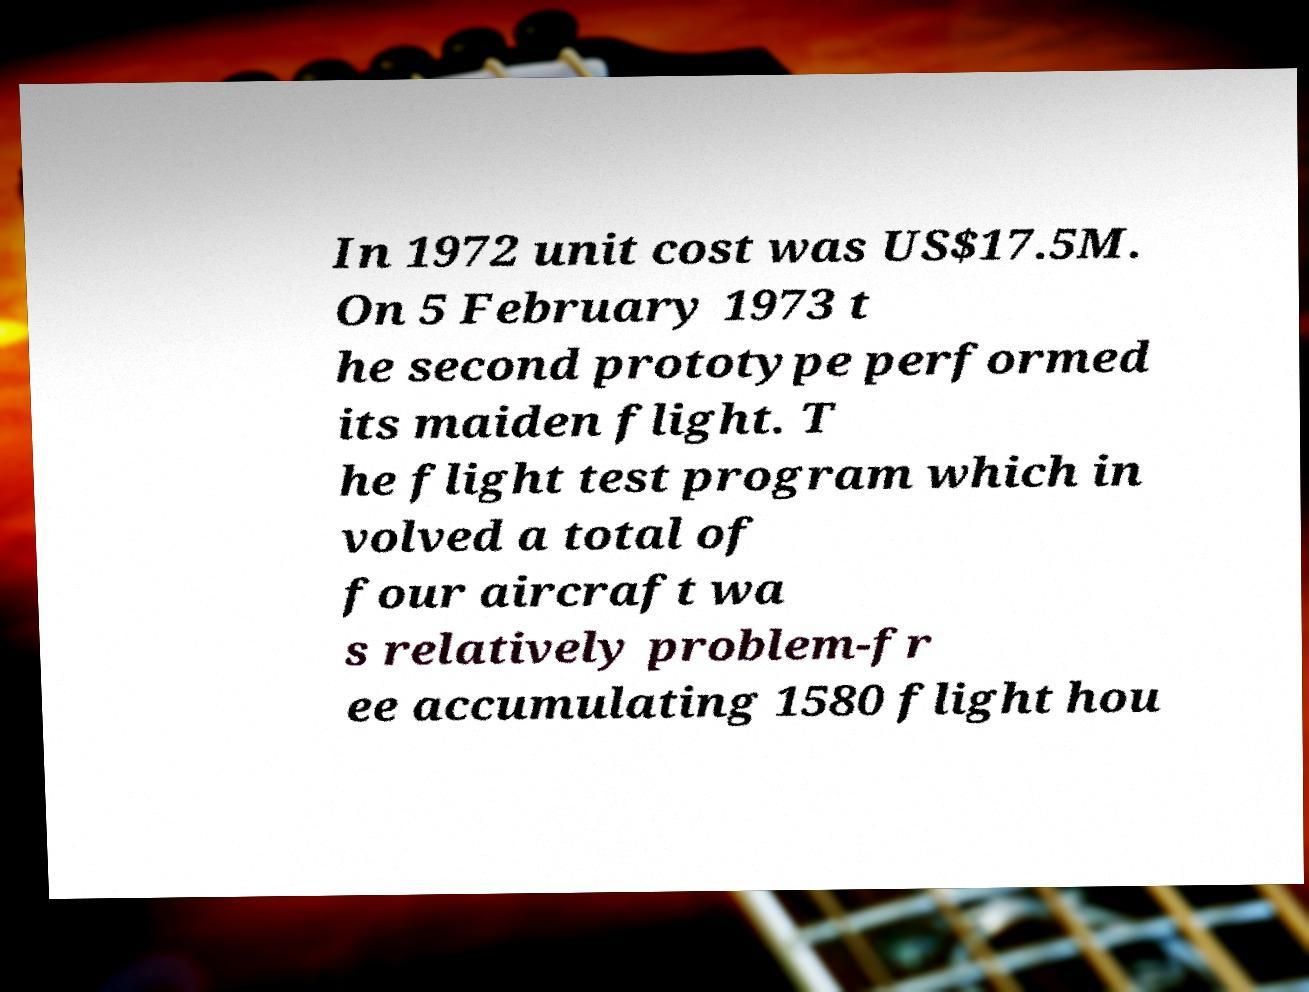Please read and relay the text visible in this image. What does it say? In 1972 unit cost was US$17.5M. On 5 February 1973 t he second prototype performed its maiden flight. T he flight test program which in volved a total of four aircraft wa s relatively problem-fr ee accumulating 1580 flight hou 